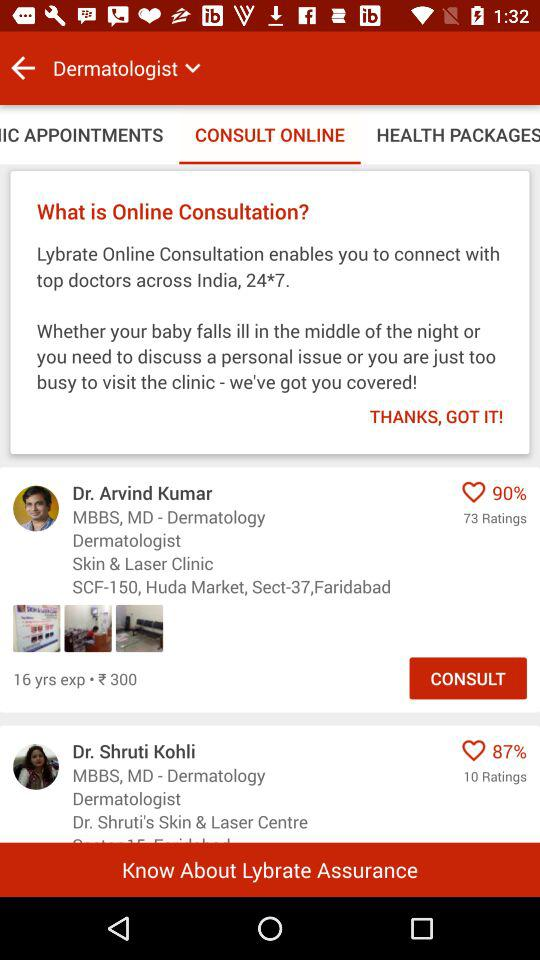How many ratings are there for Dr. Arvind Kumar? There are 73 ratings for Dr. Arvind Kumar. 